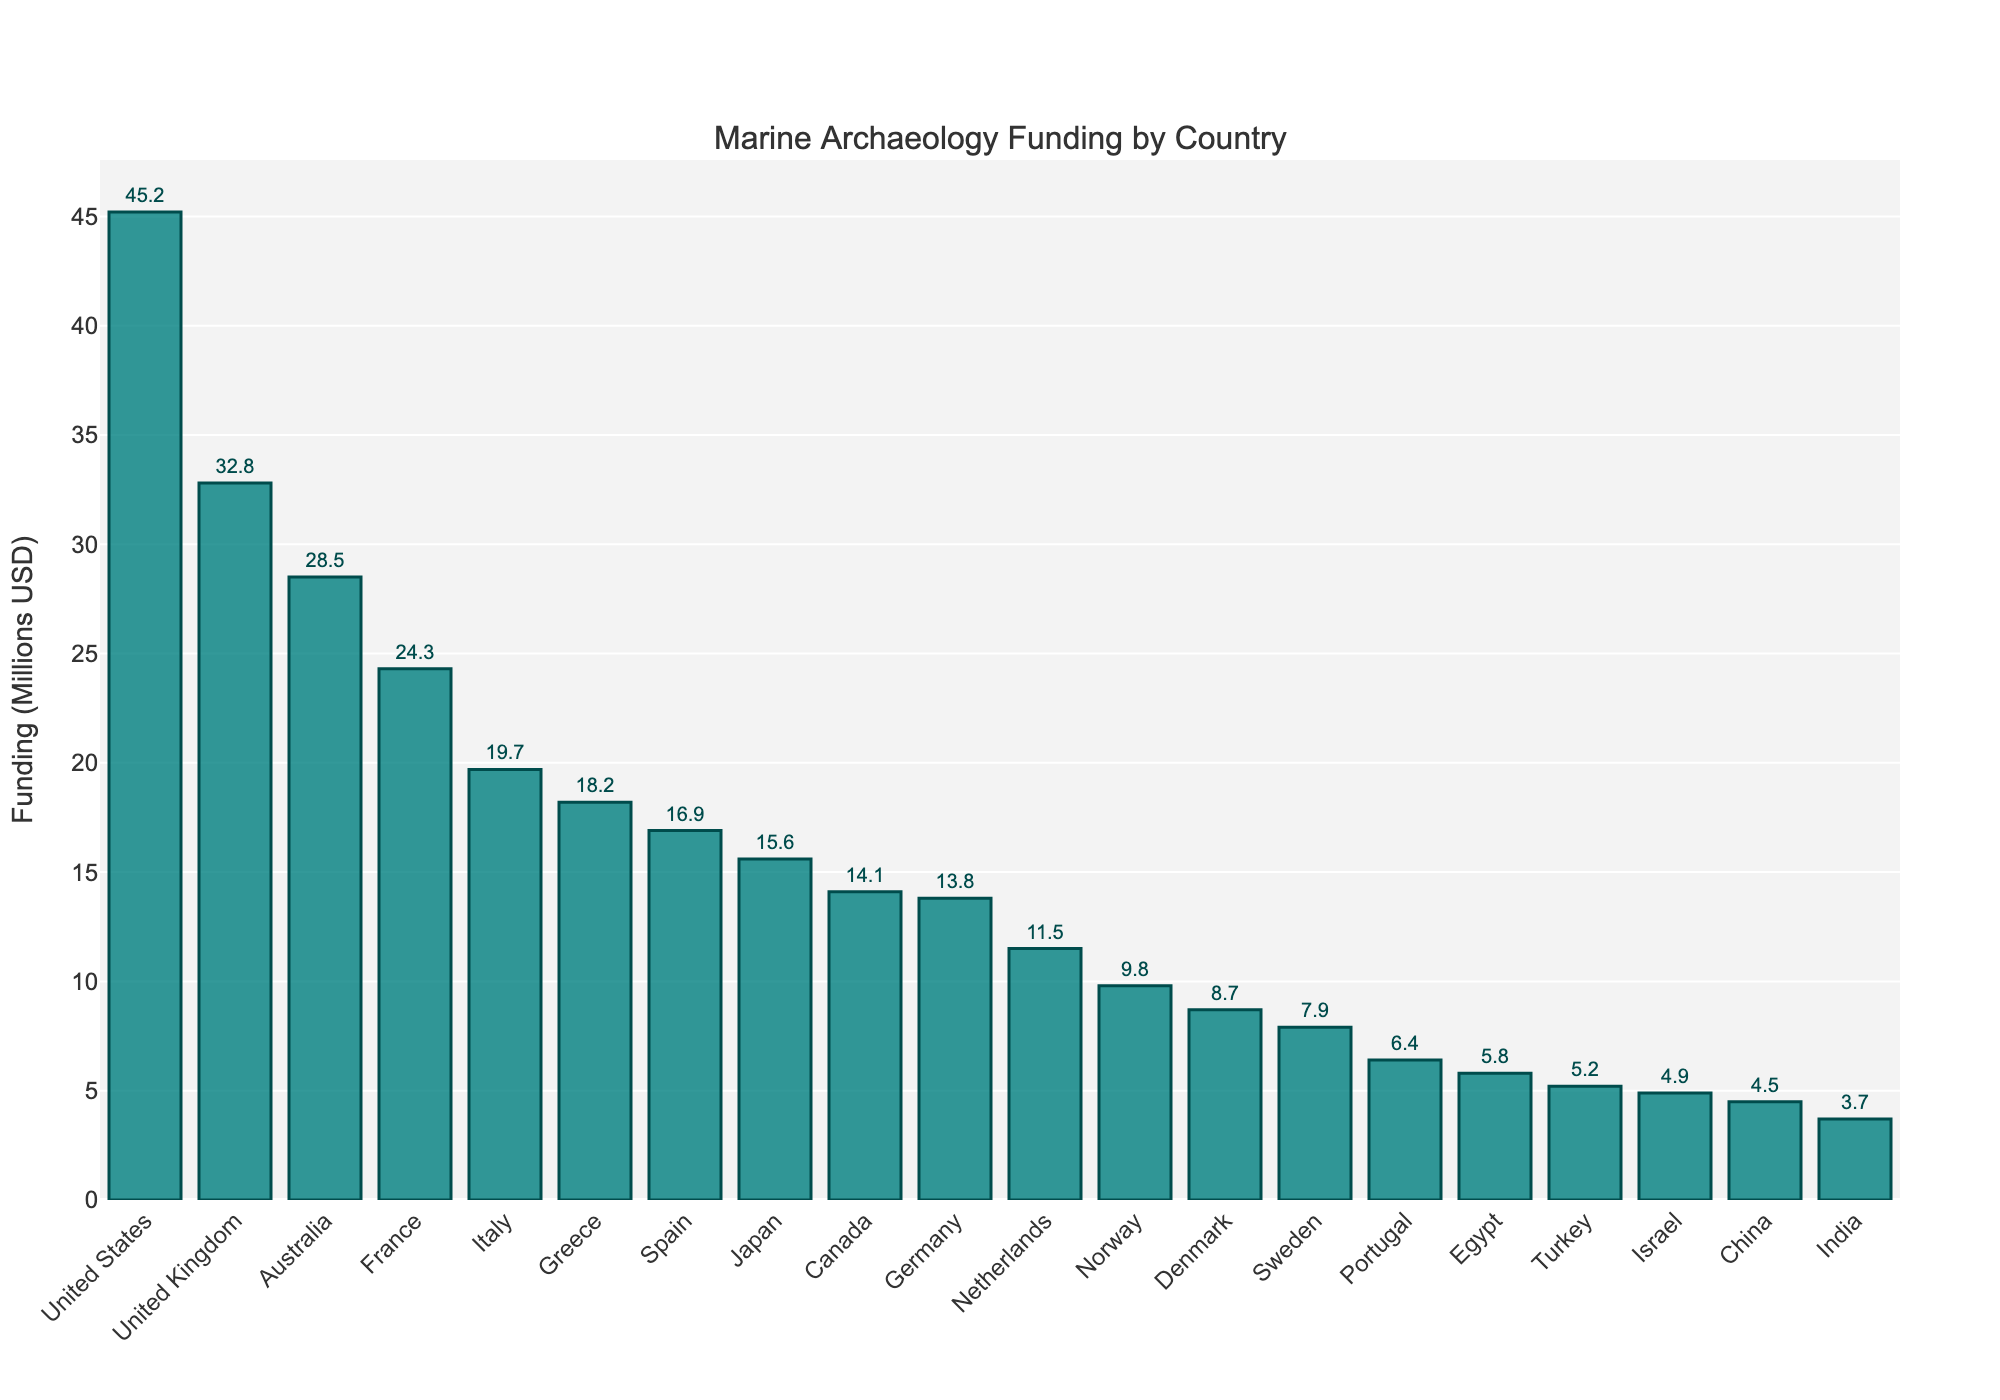What's the total funding for the top three countries? The top three countries are the United States, United Kingdom, and Australia. Summing their funding: 45.2 + 32.8 + 28.5 = 106.5
Answer: 106.5 Which country received the least funding in marine archaeology? The country with the shortest bar represents the least funding, which is India with 3.7 million USD.
Answer: India How much more funding did the United States receive compared to Germany? The United States received 45.2 million USD, while Germany received 13.8 million USD. The difference is 45.2 - 13.8 = 31.4 million USD.
Answer: 31.4 Is the funding for France greater than that of Italy and Spain combined? France received 24.3 million USD. Italy and Spain combined received 19.7 + 16.9 = 36.6 million USD, which is greater than France’s 24.3 million USD.
Answer: No What's the average funding for the countries listed? Summing all the funding amounts: 45.2 + 32.8 + 28.5 + 24.3 + 19.7 + 18.2 + 16.9 + 15.6 + 14.1 + 13.8 + 11.5 + 9.8 + 8.7 + 7.9 + 6.4 + 5.8 + 5.2 + 4.9 + 4.5 + 3.7 = 297.5. Dividing by the number of countries (20), the average is 297.5 / 20 = 14.875
Answer: 14.875 Which two countries have the closest funding amounts? The closest funding amounts can be seen visually by comparing the heights of bars: Denmark (8.7) and Sweden (7.9) are the closest, with a difference of 8.7 - 7.9 = 0.8 million USD.
Answer: Denmark and Sweden What is the median funding value across these countries? Ordering the funding amounts and finding the middle values: 3.7, 4.5, 4.9, 5.2, 5.8, 6.4, 7.9, 8.7, 9.8, 11.5, 13.8, 14.1, 15.6, 16.9, 18.2, 19.7, 24.3, 28.5, 32.8, 45.2. The middle two values are 13.8 and 14.1. So, (13.8 + 14.1) / 2 = 13.95
Answer: 13.95 Which country has the third-lowest funding and how much is it? Ordering the funding amounts in ascending order, the third-lowest funding is from Israel with 4.9 million USD.
Answer: Israel with 4.9 How does the funding for Japan compare to that of Canada? Japan received 15.6 million USD, whereas Canada received 14.1 million USD. Japan's funding is 15.6 - 14.1 = 1.5 million USD more than Canada's.
Answer: Japan received 1.5 million USD more Which country has slightly more funding than China but less than Turkey? Visual inspection shows China with 4.5 million USD, Turkey with 5.2 million USD, and Israel with 4.9 million USD fitting between them.
Answer: Israel 